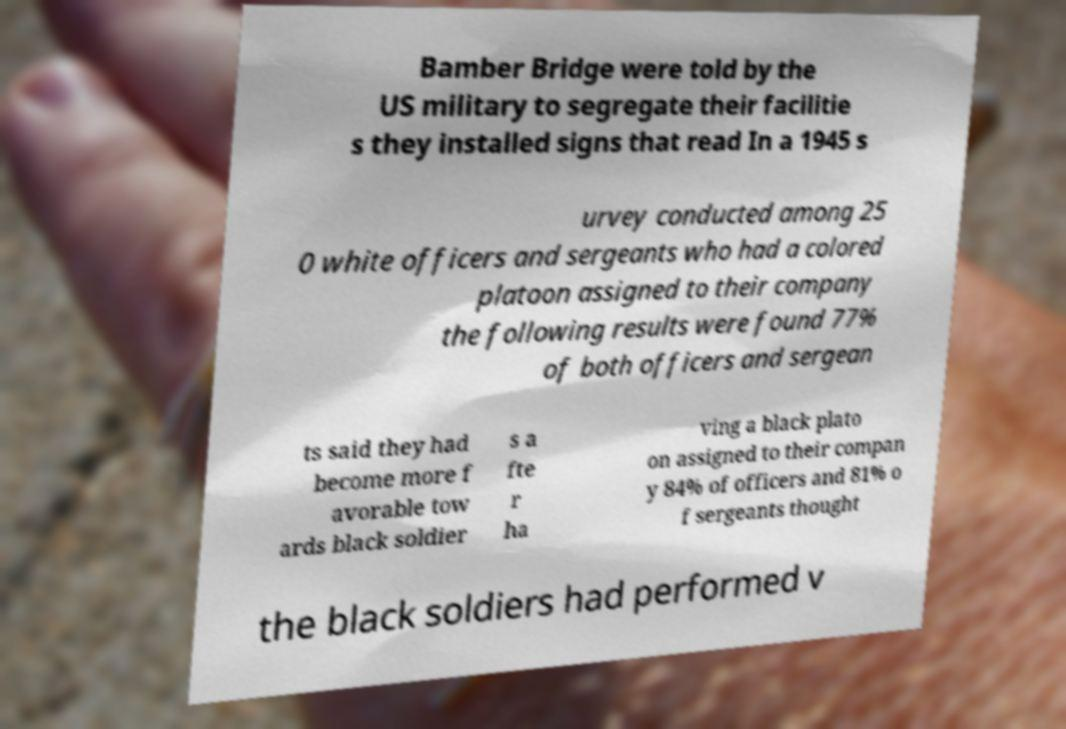I need the written content from this picture converted into text. Can you do that? Bamber Bridge were told by the US military to segregate their facilitie s they installed signs that read In a 1945 s urvey conducted among 25 0 white officers and sergeants who had a colored platoon assigned to their company the following results were found 77% of both officers and sergean ts said they had become more f avorable tow ards black soldier s a fte r ha ving a black plato on assigned to their compan y 84% of officers and 81% o f sergeants thought the black soldiers had performed v 